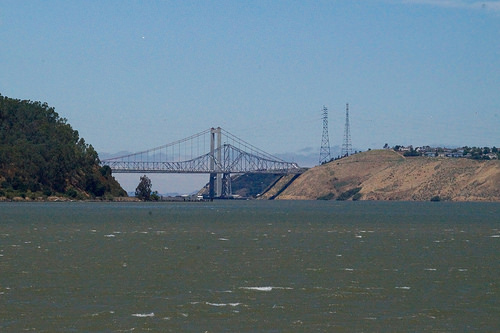<image>
Is there a water behind the mountain? No. The water is not behind the mountain. From this viewpoint, the water appears to be positioned elsewhere in the scene. 